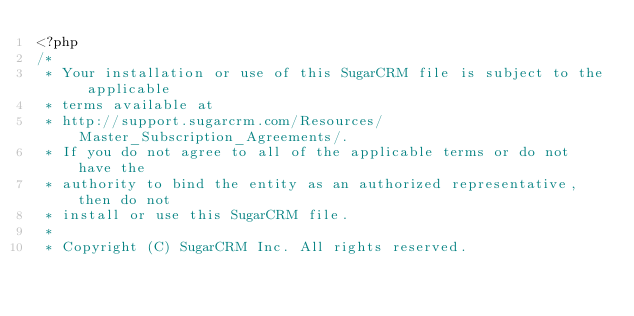<code> <loc_0><loc_0><loc_500><loc_500><_PHP_><?php
/*
 * Your installation or use of this SugarCRM file is subject to the applicable
 * terms available at
 * http://support.sugarcrm.com/Resources/Master_Subscription_Agreements/.
 * If you do not agree to all of the applicable terms or do not have the
 * authority to bind the entity as an authorized representative, then do not
 * install or use this SugarCRM file.
 *
 * Copyright (C) SugarCRM Inc. All rights reserved.</code> 